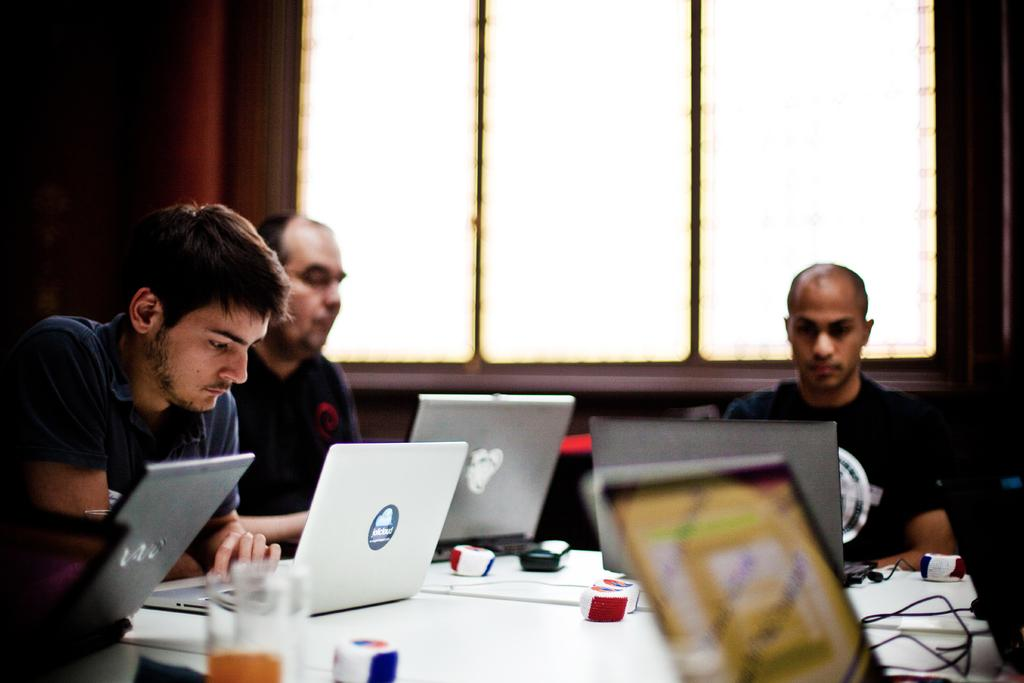What are the persons at the table doing? The persons at the table are sitting with laptops. What objects are on the table besides the laptops? There are mouses and glasses on the table. What can be seen in the background of the image? There is a wall and windows in the background. What type of jar is being used by the persons to spy on their neighbors in the image? There is no jar or spying activity present in the image. The persons are using laptops, and there are no indications of any spying or surveillance activities. 